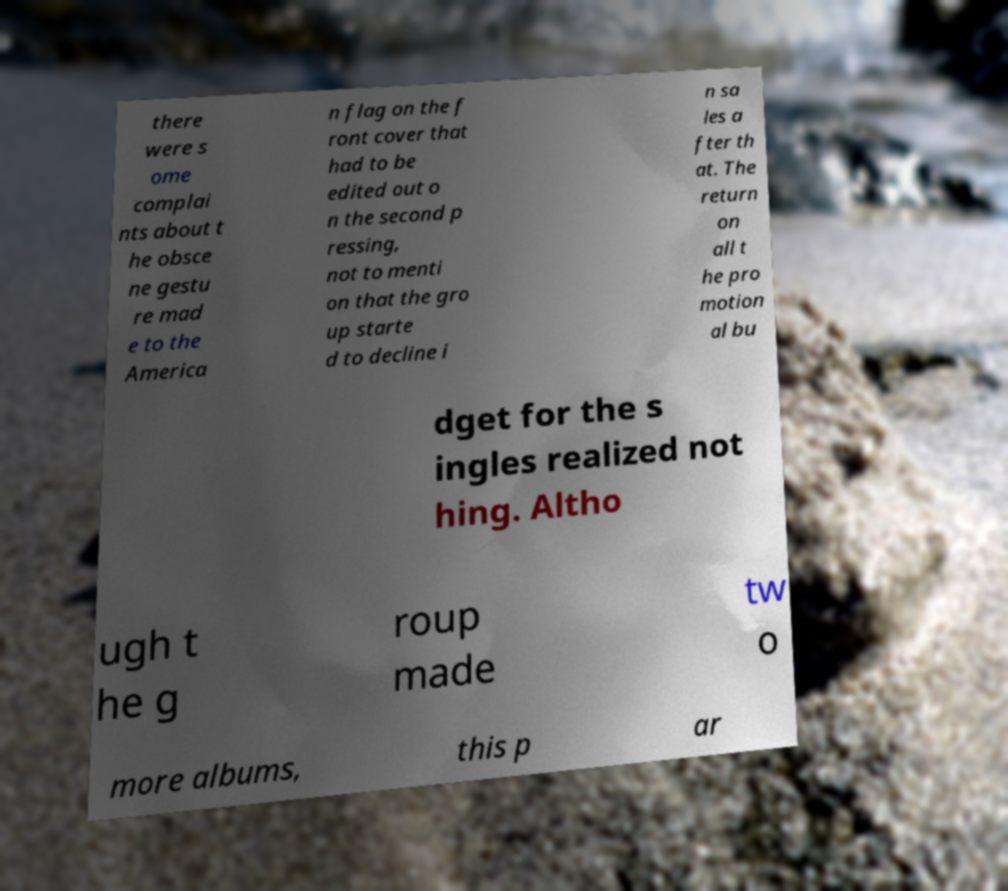Please identify and transcribe the text found in this image. there were s ome complai nts about t he obsce ne gestu re mad e to the America n flag on the f ront cover that had to be edited out o n the second p ressing, not to menti on that the gro up starte d to decline i n sa les a fter th at. The return on all t he pro motion al bu dget for the s ingles realized not hing. Altho ugh t he g roup made tw o more albums, this p ar 